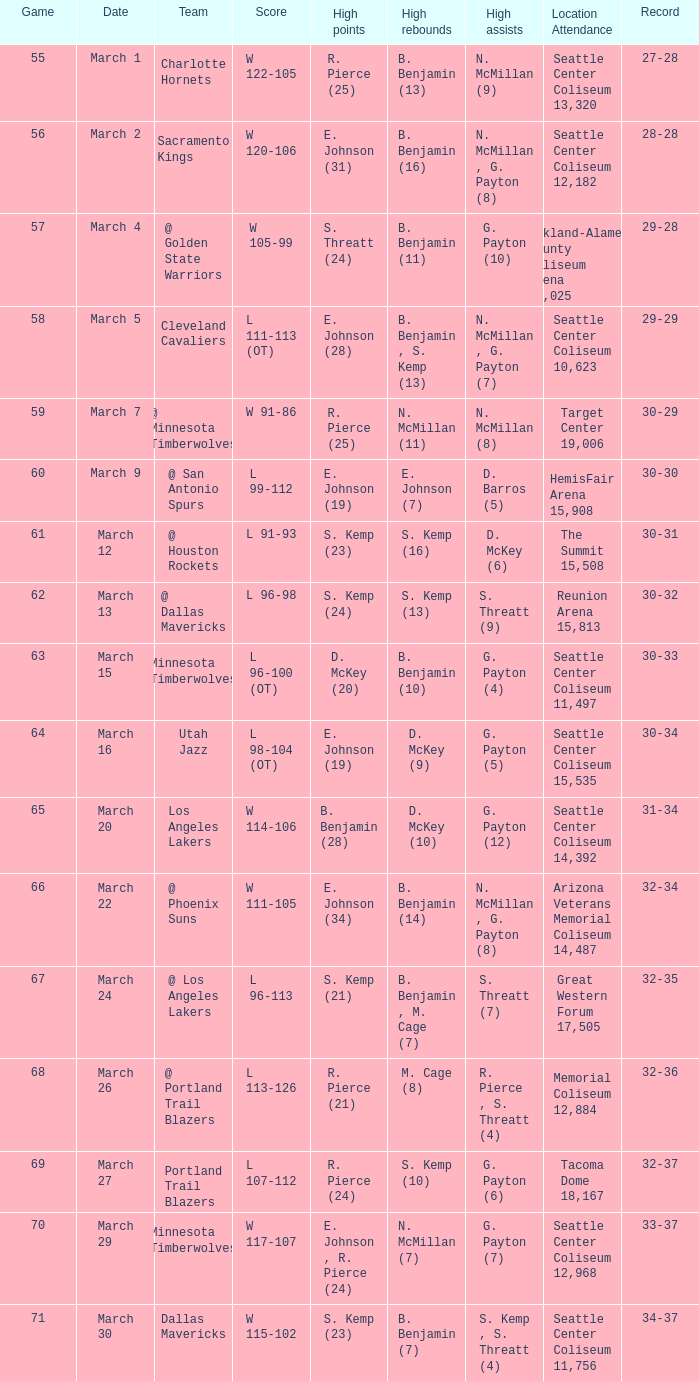Which game was played on march 2? 56.0. 